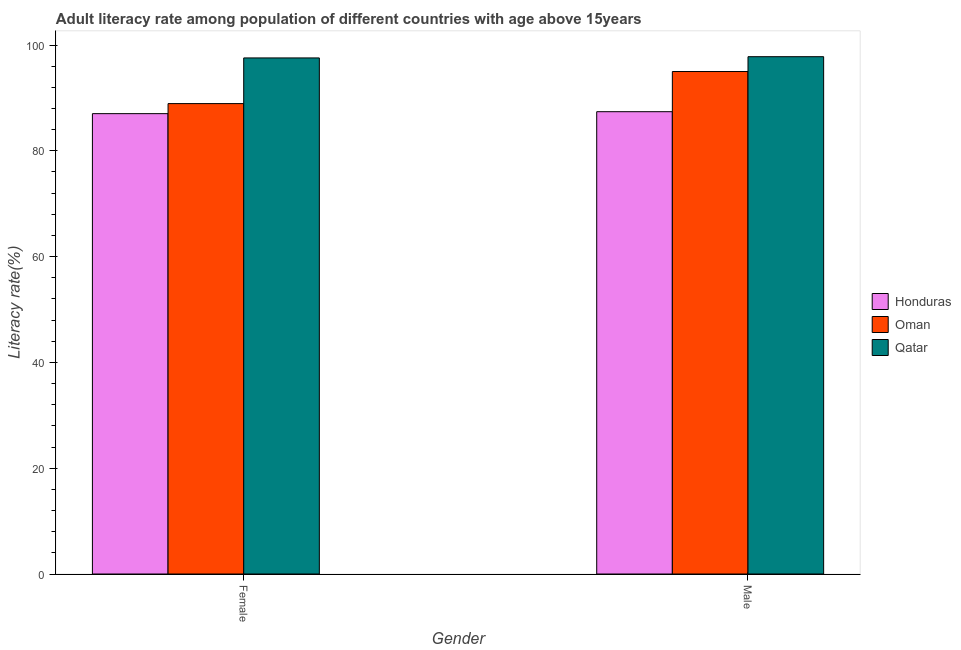How many groups of bars are there?
Keep it short and to the point. 2. Are the number of bars per tick equal to the number of legend labels?
Your answer should be compact. Yes. Are the number of bars on each tick of the X-axis equal?
Give a very brief answer. Yes. How many bars are there on the 2nd tick from the left?
Provide a short and direct response. 3. What is the female adult literacy rate in Oman?
Give a very brief answer. 88.93. Across all countries, what is the maximum male adult literacy rate?
Your answer should be very brief. 97.79. Across all countries, what is the minimum female adult literacy rate?
Your answer should be very brief. 87.03. In which country was the female adult literacy rate maximum?
Ensure brevity in your answer.  Qatar. In which country was the female adult literacy rate minimum?
Your answer should be very brief. Honduras. What is the total male adult literacy rate in the graph?
Provide a short and direct response. 280.18. What is the difference between the female adult literacy rate in Oman and that in Honduras?
Ensure brevity in your answer.  1.9. What is the difference between the male adult literacy rate in Qatar and the female adult literacy rate in Oman?
Your answer should be compact. 8.87. What is the average female adult literacy rate per country?
Ensure brevity in your answer.  91.17. What is the difference between the female adult literacy rate and male adult literacy rate in Qatar?
Your response must be concise. -0.24. In how many countries, is the female adult literacy rate greater than 28 %?
Your answer should be compact. 3. What is the ratio of the male adult literacy rate in Oman to that in Honduras?
Make the answer very short. 1.09. What does the 1st bar from the left in Male represents?
Provide a succinct answer. Honduras. What does the 3rd bar from the right in Female represents?
Provide a short and direct response. Honduras. Are all the bars in the graph horizontal?
Your response must be concise. No. Are the values on the major ticks of Y-axis written in scientific E-notation?
Ensure brevity in your answer.  No. Does the graph contain any zero values?
Your answer should be compact. No. Where does the legend appear in the graph?
Ensure brevity in your answer.  Center right. How many legend labels are there?
Your answer should be very brief. 3. What is the title of the graph?
Your answer should be very brief. Adult literacy rate among population of different countries with age above 15years. Does "Denmark" appear as one of the legend labels in the graph?
Your response must be concise. No. What is the label or title of the Y-axis?
Ensure brevity in your answer.  Literacy rate(%). What is the Literacy rate(%) of Honduras in Female?
Ensure brevity in your answer.  87.03. What is the Literacy rate(%) in Oman in Female?
Offer a very short reply. 88.93. What is the Literacy rate(%) of Qatar in Female?
Offer a terse response. 97.56. What is the Literacy rate(%) of Honduras in Male?
Ensure brevity in your answer.  87.4. What is the Literacy rate(%) in Oman in Male?
Give a very brief answer. 94.99. What is the Literacy rate(%) of Qatar in Male?
Provide a short and direct response. 97.79. Across all Gender, what is the maximum Literacy rate(%) in Honduras?
Offer a terse response. 87.4. Across all Gender, what is the maximum Literacy rate(%) of Oman?
Ensure brevity in your answer.  94.99. Across all Gender, what is the maximum Literacy rate(%) in Qatar?
Make the answer very short. 97.79. Across all Gender, what is the minimum Literacy rate(%) of Honduras?
Your answer should be compact. 87.03. Across all Gender, what is the minimum Literacy rate(%) in Oman?
Give a very brief answer. 88.93. Across all Gender, what is the minimum Literacy rate(%) in Qatar?
Give a very brief answer. 97.56. What is the total Literacy rate(%) of Honduras in the graph?
Provide a short and direct response. 174.42. What is the total Literacy rate(%) in Oman in the graph?
Provide a succinct answer. 183.92. What is the total Literacy rate(%) of Qatar in the graph?
Keep it short and to the point. 195.35. What is the difference between the Literacy rate(%) in Honduras in Female and that in Male?
Make the answer very short. -0.37. What is the difference between the Literacy rate(%) of Oman in Female and that in Male?
Give a very brief answer. -6.06. What is the difference between the Literacy rate(%) of Qatar in Female and that in Male?
Your answer should be compact. -0.24. What is the difference between the Literacy rate(%) in Honduras in Female and the Literacy rate(%) in Oman in Male?
Offer a terse response. -7.96. What is the difference between the Literacy rate(%) in Honduras in Female and the Literacy rate(%) in Qatar in Male?
Your response must be concise. -10.77. What is the difference between the Literacy rate(%) in Oman in Female and the Literacy rate(%) in Qatar in Male?
Your response must be concise. -8.87. What is the average Literacy rate(%) in Honduras per Gender?
Provide a short and direct response. 87.21. What is the average Literacy rate(%) of Oman per Gender?
Your answer should be compact. 91.96. What is the average Literacy rate(%) in Qatar per Gender?
Your answer should be very brief. 97.68. What is the difference between the Literacy rate(%) of Honduras and Literacy rate(%) of Oman in Female?
Offer a very short reply. -1.9. What is the difference between the Literacy rate(%) of Honduras and Literacy rate(%) of Qatar in Female?
Your answer should be compact. -10.53. What is the difference between the Literacy rate(%) of Oman and Literacy rate(%) of Qatar in Female?
Give a very brief answer. -8.63. What is the difference between the Literacy rate(%) in Honduras and Literacy rate(%) in Oman in Male?
Provide a short and direct response. -7.59. What is the difference between the Literacy rate(%) of Honduras and Literacy rate(%) of Qatar in Male?
Ensure brevity in your answer.  -10.4. What is the difference between the Literacy rate(%) of Oman and Literacy rate(%) of Qatar in Male?
Your response must be concise. -2.8. What is the ratio of the Literacy rate(%) of Oman in Female to that in Male?
Keep it short and to the point. 0.94. What is the difference between the highest and the second highest Literacy rate(%) in Honduras?
Offer a terse response. 0.37. What is the difference between the highest and the second highest Literacy rate(%) of Oman?
Your response must be concise. 6.06. What is the difference between the highest and the second highest Literacy rate(%) of Qatar?
Make the answer very short. 0.24. What is the difference between the highest and the lowest Literacy rate(%) of Honduras?
Your answer should be compact. 0.37. What is the difference between the highest and the lowest Literacy rate(%) in Oman?
Ensure brevity in your answer.  6.06. What is the difference between the highest and the lowest Literacy rate(%) in Qatar?
Make the answer very short. 0.24. 